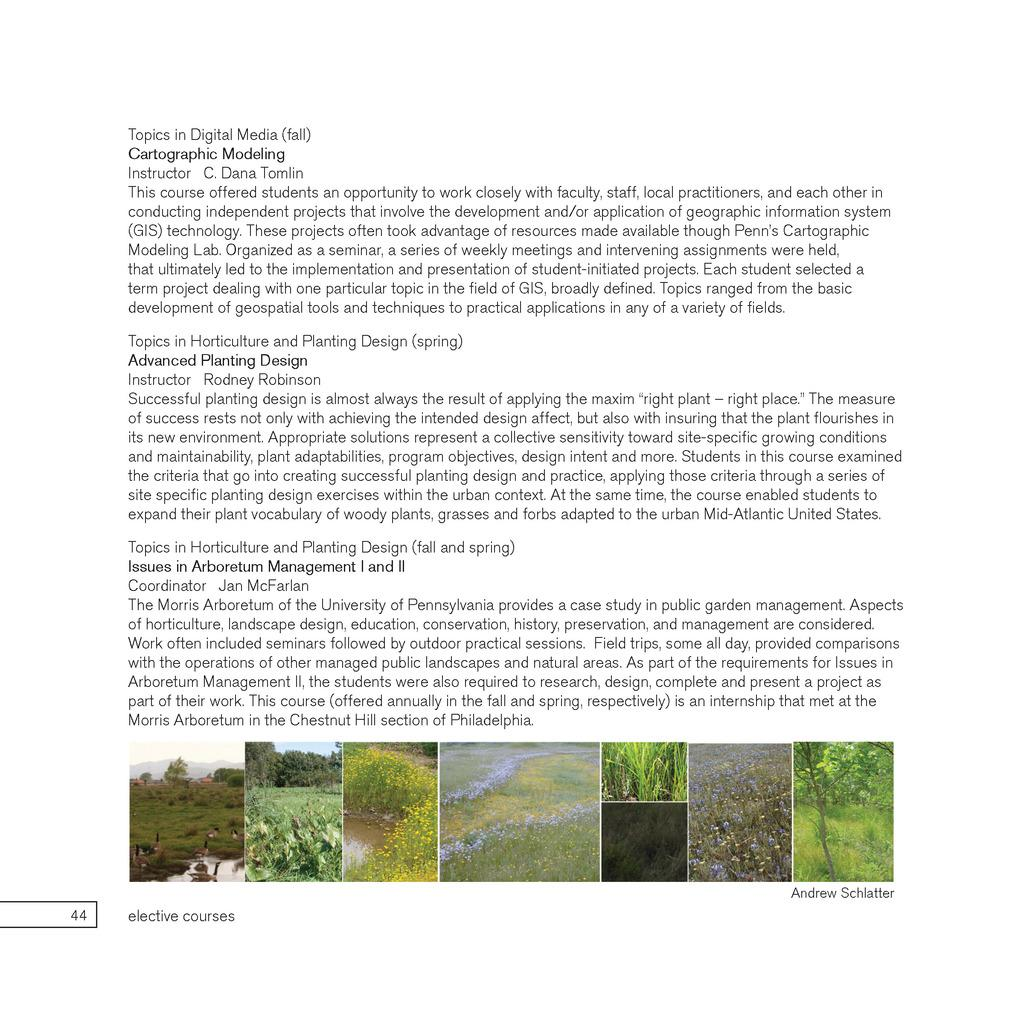What type of content is present in the image? The image contains an article. What kind of images are included in the article? The article has images of plants and trees. What type of cracker is being used to illustrate the article's content? There is no cracker present in the image; the article contains images of plants and trees. How does the army relate to the content of the article? The army is not mentioned or depicted in the image, as it contains an article about plants and trees. 